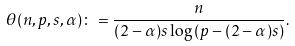Convert formula to latex. <formula><loc_0><loc_0><loc_500><loc_500>\theta ( n , p , s , \alpha ) \colon = \frac { n } { ( 2 - \alpha ) s \log \left ( p - ( 2 - \alpha ) s \right ) } .</formula> 